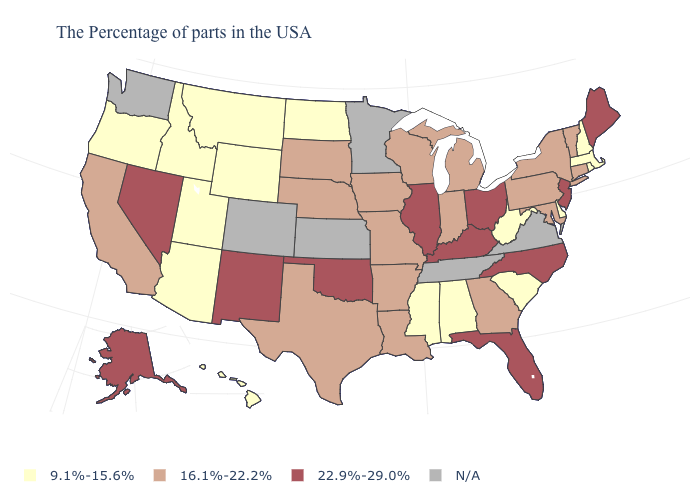Among the states that border Kentucky , does West Virginia have the lowest value?
Quick response, please. Yes. Name the states that have a value in the range 9.1%-15.6%?
Give a very brief answer. Massachusetts, Rhode Island, New Hampshire, Delaware, South Carolina, West Virginia, Alabama, Mississippi, North Dakota, Wyoming, Utah, Montana, Arizona, Idaho, Oregon, Hawaii. Which states have the lowest value in the USA?
Concise answer only. Massachusetts, Rhode Island, New Hampshire, Delaware, South Carolina, West Virginia, Alabama, Mississippi, North Dakota, Wyoming, Utah, Montana, Arizona, Idaho, Oregon, Hawaii. Is the legend a continuous bar?
Answer briefly. No. Name the states that have a value in the range N/A?
Be succinct. Virginia, Tennessee, Minnesota, Kansas, Colorado, Washington. Which states have the lowest value in the West?
Write a very short answer. Wyoming, Utah, Montana, Arizona, Idaho, Oregon, Hawaii. Among the states that border Nevada , which have the highest value?
Keep it brief. California. Which states have the highest value in the USA?
Answer briefly. Maine, New Jersey, North Carolina, Ohio, Florida, Kentucky, Illinois, Oklahoma, New Mexico, Nevada, Alaska. What is the value of Texas?
Be succinct. 16.1%-22.2%. What is the value of Wyoming?
Write a very short answer. 9.1%-15.6%. Is the legend a continuous bar?
Give a very brief answer. No. What is the lowest value in the USA?
Concise answer only. 9.1%-15.6%. Name the states that have a value in the range 16.1%-22.2%?
Quick response, please. Vermont, Connecticut, New York, Maryland, Pennsylvania, Georgia, Michigan, Indiana, Wisconsin, Louisiana, Missouri, Arkansas, Iowa, Nebraska, Texas, South Dakota, California. What is the value of Virginia?
Be succinct. N/A. Name the states that have a value in the range 16.1%-22.2%?
Concise answer only. Vermont, Connecticut, New York, Maryland, Pennsylvania, Georgia, Michigan, Indiana, Wisconsin, Louisiana, Missouri, Arkansas, Iowa, Nebraska, Texas, South Dakota, California. 